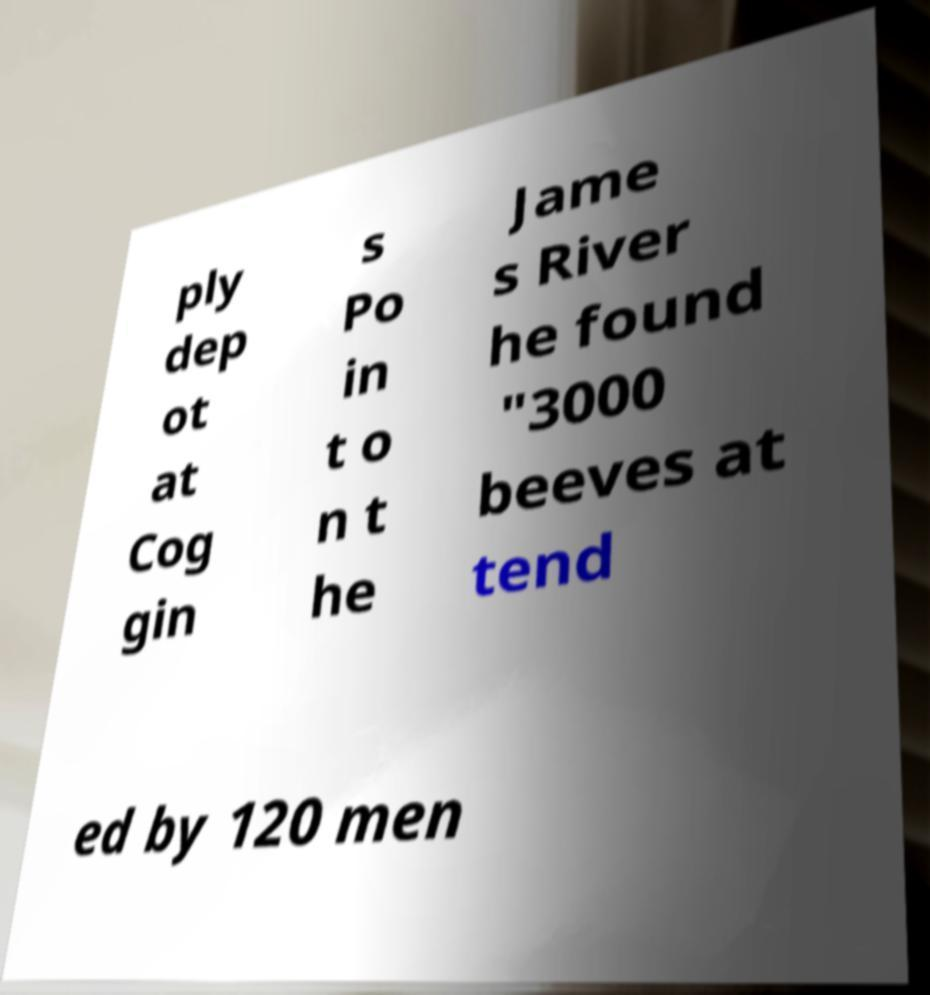For documentation purposes, I need the text within this image transcribed. Could you provide that? ply dep ot at Cog gin s Po in t o n t he Jame s River he found "3000 beeves at tend ed by 120 men 